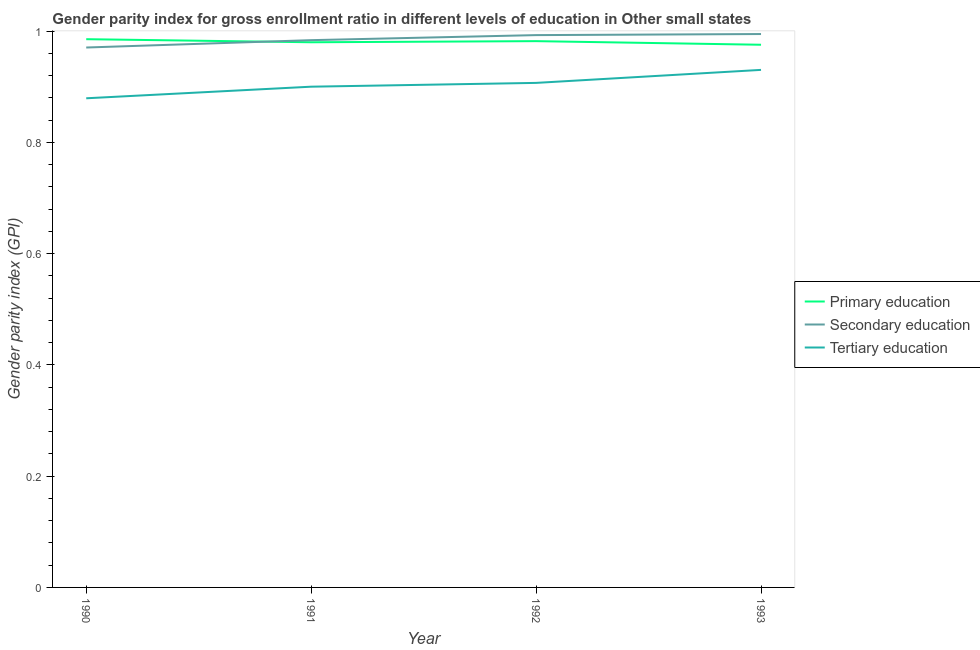How many different coloured lines are there?
Offer a very short reply. 3. Is the number of lines equal to the number of legend labels?
Make the answer very short. Yes. What is the gender parity index in secondary education in 1993?
Provide a short and direct response. 0.99. Across all years, what is the maximum gender parity index in secondary education?
Your answer should be very brief. 0.99. Across all years, what is the minimum gender parity index in tertiary education?
Provide a succinct answer. 0.88. In which year was the gender parity index in tertiary education maximum?
Provide a succinct answer. 1993. In which year was the gender parity index in primary education minimum?
Make the answer very short. 1993. What is the total gender parity index in tertiary education in the graph?
Keep it short and to the point. 3.62. What is the difference between the gender parity index in tertiary education in 1990 and that in 1992?
Offer a very short reply. -0.03. What is the difference between the gender parity index in secondary education in 1993 and the gender parity index in tertiary education in 1991?
Your response must be concise. 0.09. What is the average gender parity index in primary education per year?
Offer a very short reply. 0.98. In the year 1992, what is the difference between the gender parity index in secondary education and gender parity index in primary education?
Provide a short and direct response. 0.01. What is the ratio of the gender parity index in primary education in 1990 to that in 1993?
Your answer should be very brief. 1.01. Is the difference between the gender parity index in secondary education in 1991 and 1992 greater than the difference between the gender parity index in tertiary education in 1991 and 1992?
Keep it short and to the point. No. What is the difference between the highest and the second highest gender parity index in primary education?
Your response must be concise. 0. What is the difference between the highest and the lowest gender parity index in secondary education?
Provide a succinct answer. 0.02. Does the gender parity index in secondary education monotonically increase over the years?
Offer a terse response. Yes. Is the gender parity index in tertiary education strictly greater than the gender parity index in primary education over the years?
Offer a very short reply. No. How many years are there in the graph?
Your answer should be very brief. 4. What is the difference between two consecutive major ticks on the Y-axis?
Ensure brevity in your answer.  0.2. Does the graph contain grids?
Offer a terse response. No. Where does the legend appear in the graph?
Your response must be concise. Center right. How many legend labels are there?
Keep it short and to the point. 3. How are the legend labels stacked?
Make the answer very short. Vertical. What is the title of the graph?
Offer a very short reply. Gender parity index for gross enrollment ratio in different levels of education in Other small states. What is the label or title of the X-axis?
Offer a terse response. Year. What is the label or title of the Y-axis?
Offer a terse response. Gender parity index (GPI). What is the Gender parity index (GPI) in Primary education in 1990?
Provide a succinct answer. 0.99. What is the Gender parity index (GPI) of Secondary education in 1990?
Provide a succinct answer. 0.97. What is the Gender parity index (GPI) of Tertiary education in 1990?
Give a very brief answer. 0.88. What is the Gender parity index (GPI) in Primary education in 1991?
Offer a very short reply. 0.98. What is the Gender parity index (GPI) in Secondary education in 1991?
Offer a terse response. 0.98. What is the Gender parity index (GPI) of Tertiary education in 1991?
Provide a succinct answer. 0.9. What is the Gender parity index (GPI) in Primary education in 1992?
Ensure brevity in your answer.  0.98. What is the Gender parity index (GPI) of Secondary education in 1992?
Provide a short and direct response. 0.99. What is the Gender parity index (GPI) of Tertiary education in 1992?
Your answer should be compact. 0.91. What is the Gender parity index (GPI) of Primary education in 1993?
Offer a terse response. 0.98. What is the Gender parity index (GPI) of Secondary education in 1993?
Your answer should be very brief. 0.99. What is the Gender parity index (GPI) of Tertiary education in 1993?
Provide a succinct answer. 0.93. Across all years, what is the maximum Gender parity index (GPI) of Primary education?
Provide a short and direct response. 0.99. Across all years, what is the maximum Gender parity index (GPI) in Secondary education?
Ensure brevity in your answer.  0.99. Across all years, what is the maximum Gender parity index (GPI) in Tertiary education?
Provide a succinct answer. 0.93. Across all years, what is the minimum Gender parity index (GPI) in Primary education?
Provide a succinct answer. 0.98. Across all years, what is the minimum Gender parity index (GPI) in Secondary education?
Give a very brief answer. 0.97. Across all years, what is the minimum Gender parity index (GPI) in Tertiary education?
Offer a very short reply. 0.88. What is the total Gender parity index (GPI) of Primary education in the graph?
Provide a short and direct response. 3.92. What is the total Gender parity index (GPI) in Secondary education in the graph?
Ensure brevity in your answer.  3.94. What is the total Gender parity index (GPI) of Tertiary education in the graph?
Give a very brief answer. 3.62. What is the difference between the Gender parity index (GPI) in Primary education in 1990 and that in 1991?
Make the answer very short. 0.01. What is the difference between the Gender parity index (GPI) of Secondary education in 1990 and that in 1991?
Your answer should be very brief. -0.01. What is the difference between the Gender parity index (GPI) of Tertiary education in 1990 and that in 1991?
Provide a short and direct response. -0.02. What is the difference between the Gender parity index (GPI) in Primary education in 1990 and that in 1992?
Provide a succinct answer. 0. What is the difference between the Gender parity index (GPI) in Secondary education in 1990 and that in 1992?
Your answer should be very brief. -0.02. What is the difference between the Gender parity index (GPI) in Tertiary education in 1990 and that in 1992?
Offer a terse response. -0.03. What is the difference between the Gender parity index (GPI) in Primary education in 1990 and that in 1993?
Your answer should be very brief. 0.01. What is the difference between the Gender parity index (GPI) in Secondary education in 1990 and that in 1993?
Offer a terse response. -0.02. What is the difference between the Gender parity index (GPI) in Tertiary education in 1990 and that in 1993?
Your answer should be compact. -0.05. What is the difference between the Gender parity index (GPI) of Primary education in 1991 and that in 1992?
Your answer should be very brief. -0. What is the difference between the Gender parity index (GPI) of Secondary education in 1991 and that in 1992?
Make the answer very short. -0.01. What is the difference between the Gender parity index (GPI) of Tertiary education in 1991 and that in 1992?
Give a very brief answer. -0.01. What is the difference between the Gender parity index (GPI) in Primary education in 1991 and that in 1993?
Keep it short and to the point. 0. What is the difference between the Gender parity index (GPI) in Secondary education in 1991 and that in 1993?
Make the answer very short. -0.01. What is the difference between the Gender parity index (GPI) in Tertiary education in 1991 and that in 1993?
Provide a succinct answer. -0.03. What is the difference between the Gender parity index (GPI) in Primary education in 1992 and that in 1993?
Give a very brief answer. 0.01. What is the difference between the Gender parity index (GPI) of Secondary education in 1992 and that in 1993?
Your answer should be very brief. -0. What is the difference between the Gender parity index (GPI) of Tertiary education in 1992 and that in 1993?
Make the answer very short. -0.02. What is the difference between the Gender parity index (GPI) of Primary education in 1990 and the Gender parity index (GPI) of Secondary education in 1991?
Offer a very short reply. 0. What is the difference between the Gender parity index (GPI) in Primary education in 1990 and the Gender parity index (GPI) in Tertiary education in 1991?
Keep it short and to the point. 0.09. What is the difference between the Gender parity index (GPI) of Secondary education in 1990 and the Gender parity index (GPI) of Tertiary education in 1991?
Keep it short and to the point. 0.07. What is the difference between the Gender parity index (GPI) in Primary education in 1990 and the Gender parity index (GPI) in Secondary education in 1992?
Your answer should be compact. -0.01. What is the difference between the Gender parity index (GPI) in Primary education in 1990 and the Gender parity index (GPI) in Tertiary education in 1992?
Make the answer very short. 0.08. What is the difference between the Gender parity index (GPI) of Secondary education in 1990 and the Gender parity index (GPI) of Tertiary education in 1992?
Your answer should be very brief. 0.06. What is the difference between the Gender parity index (GPI) in Primary education in 1990 and the Gender parity index (GPI) in Secondary education in 1993?
Make the answer very short. -0.01. What is the difference between the Gender parity index (GPI) in Primary education in 1990 and the Gender parity index (GPI) in Tertiary education in 1993?
Provide a short and direct response. 0.06. What is the difference between the Gender parity index (GPI) in Secondary education in 1990 and the Gender parity index (GPI) in Tertiary education in 1993?
Your answer should be compact. 0.04. What is the difference between the Gender parity index (GPI) in Primary education in 1991 and the Gender parity index (GPI) in Secondary education in 1992?
Make the answer very short. -0.01. What is the difference between the Gender parity index (GPI) of Primary education in 1991 and the Gender parity index (GPI) of Tertiary education in 1992?
Provide a short and direct response. 0.07. What is the difference between the Gender parity index (GPI) of Secondary education in 1991 and the Gender parity index (GPI) of Tertiary education in 1992?
Provide a succinct answer. 0.08. What is the difference between the Gender parity index (GPI) in Primary education in 1991 and the Gender parity index (GPI) in Secondary education in 1993?
Provide a short and direct response. -0.01. What is the difference between the Gender parity index (GPI) in Primary education in 1991 and the Gender parity index (GPI) in Tertiary education in 1993?
Keep it short and to the point. 0.05. What is the difference between the Gender parity index (GPI) in Secondary education in 1991 and the Gender parity index (GPI) in Tertiary education in 1993?
Offer a very short reply. 0.05. What is the difference between the Gender parity index (GPI) in Primary education in 1992 and the Gender parity index (GPI) in Secondary education in 1993?
Your response must be concise. -0.01. What is the difference between the Gender parity index (GPI) in Primary education in 1992 and the Gender parity index (GPI) in Tertiary education in 1993?
Provide a succinct answer. 0.05. What is the difference between the Gender parity index (GPI) in Secondary education in 1992 and the Gender parity index (GPI) in Tertiary education in 1993?
Make the answer very short. 0.06. What is the average Gender parity index (GPI) of Primary education per year?
Ensure brevity in your answer.  0.98. What is the average Gender parity index (GPI) in Secondary education per year?
Give a very brief answer. 0.99. What is the average Gender parity index (GPI) in Tertiary education per year?
Offer a very short reply. 0.9. In the year 1990, what is the difference between the Gender parity index (GPI) in Primary education and Gender parity index (GPI) in Secondary education?
Provide a short and direct response. 0.01. In the year 1990, what is the difference between the Gender parity index (GPI) of Primary education and Gender parity index (GPI) of Tertiary education?
Give a very brief answer. 0.11. In the year 1990, what is the difference between the Gender parity index (GPI) in Secondary education and Gender parity index (GPI) in Tertiary education?
Your answer should be very brief. 0.09. In the year 1991, what is the difference between the Gender parity index (GPI) in Primary education and Gender parity index (GPI) in Secondary education?
Give a very brief answer. -0. In the year 1991, what is the difference between the Gender parity index (GPI) in Primary education and Gender parity index (GPI) in Tertiary education?
Keep it short and to the point. 0.08. In the year 1991, what is the difference between the Gender parity index (GPI) in Secondary education and Gender parity index (GPI) in Tertiary education?
Give a very brief answer. 0.08. In the year 1992, what is the difference between the Gender parity index (GPI) in Primary education and Gender parity index (GPI) in Secondary education?
Offer a terse response. -0.01. In the year 1992, what is the difference between the Gender parity index (GPI) of Primary education and Gender parity index (GPI) of Tertiary education?
Make the answer very short. 0.08. In the year 1992, what is the difference between the Gender parity index (GPI) in Secondary education and Gender parity index (GPI) in Tertiary education?
Give a very brief answer. 0.09. In the year 1993, what is the difference between the Gender parity index (GPI) of Primary education and Gender parity index (GPI) of Secondary education?
Offer a terse response. -0.02. In the year 1993, what is the difference between the Gender parity index (GPI) in Primary education and Gender parity index (GPI) in Tertiary education?
Your answer should be very brief. 0.05. In the year 1993, what is the difference between the Gender parity index (GPI) in Secondary education and Gender parity index (GPI) in Tertiary education?
Ensure brevity in your answer.  0.06. What is the ratio of the Gender parity index (GPI) in Primary education in 1990 to that in 1991?
Provide a succinct answer. 1.01. What is the ratio of the Gender parity index (GPI) of Secondary education in 1990 to that in 1991?
Ensure brevity in your answer.  0.99. What is the ratio of the Gender parity index (GPI) of Tertiary education in 1990 to that in 1991?
Your answer should be very brief. 0.98. What is the ratio of the Gender parity index (GPI) of Primary education in 1990 to that in 1992?
Give a very brief answer. 1. What is the ratio of the Gender parity index (GPI) of Secondary education in 1990 to that in 1992?
Your answer should be very brief. 0.98. What is the ratio of the Gender parity index (GPI) in Tertiary education in 1990 to that in 1992?
Your response must be concise. 0.97. What is the ratio of the Gender parity index (GPI) of Primary education in 1990 to that in 1993?
Your answer should be very brief. 1.01. What is the ratio of the Gender parity index (GPI) in Secondary education in 1990 to that in 1993?
Offer a very short reply. 0.98. What is the ratio of the Gender parity index (GPI) of Tertiary education in 1990 to that in 1993?
Offer a terse response. 0.95. What is the ratio of the Gender parity index (GPI) in Primary education in 1991 to that in 1992?
Provide a short and direct response. 1. What is the ratio of the Gender parity index (GPI) of Secondary education in 1991 to that in 1992?
Offer a terse response. 0.99. What is the ratio of the Gender parity index (GPI) of Tertiary education in 1991 to that in 1992?
Give a very brief answer. 0.99. What is the ratio of the Gender parity index (GPI) in Primary education in 1991 to that in 1993?
Provide a short and direct response. 1. What is the ratio of the Gender parity index (GPI) of Secondary education in 1991 to that in 1993?
Provide a short and direct response. 0.99. What is the ratio of the Gender parity index (GPI) of Tertiary education in 1991 to that in 1993?
Give a very brief answer. 0.97. What is the ratio of the Gender parity index (GPI) of Tertiary education in 1992 to that in 1993?
Provide a short and direct response. 0.97. What is the difference between the highest and the second highest Gender parity index (GPI) of Primary education?
Provide a succinct answer. 0. What is the difference between the highest and the second highest Gender parity index (GPI) in Secondary education?
Make the answer very short. 0. What is the difference between the highest and the second highest Gender parity index (GPI) of Tertiary education?
Provide a short and direct response. 0.02. What is the difference between the highest and the lowest Gender parity index (GPI) in Primary education?
Offer a terse response. 0.01. What is the difference between the highest and the lowest Gender parity index (GPI) in Secondary education?
Keep it short and to the point. 0.02. What is the difference between the highest and the lowest Gender parity index (GPI) of Tertiary education?
Your response must be concise. 0.05. 